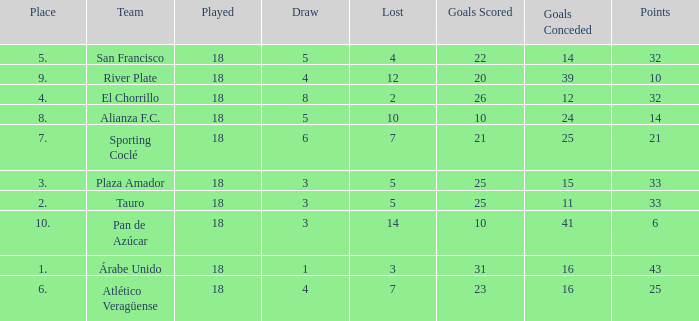How many goals were conceded by the team with more than 21 points more than 5 draws and less than 18 games played? None. 